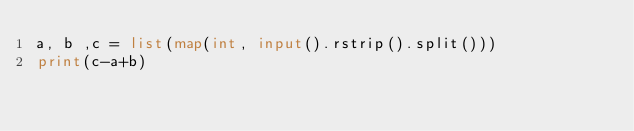<code> <loc_0><loc_0><loc_500><loc_500><_Python_>a, b ,c = list(map(int, input().rstrip().split()))
print(c-a+b)</code> 